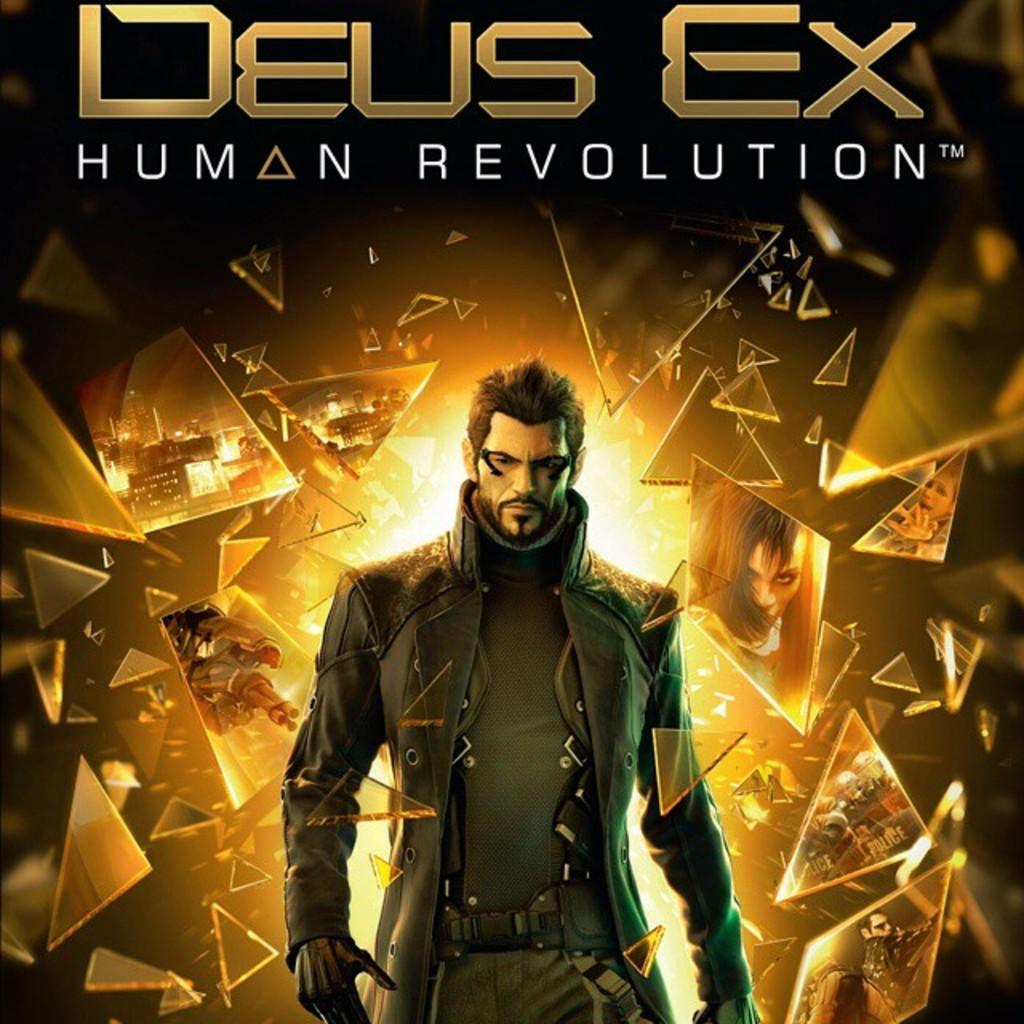What is the title of this?
Provide a succinct answer. Deus ex human revolution. 